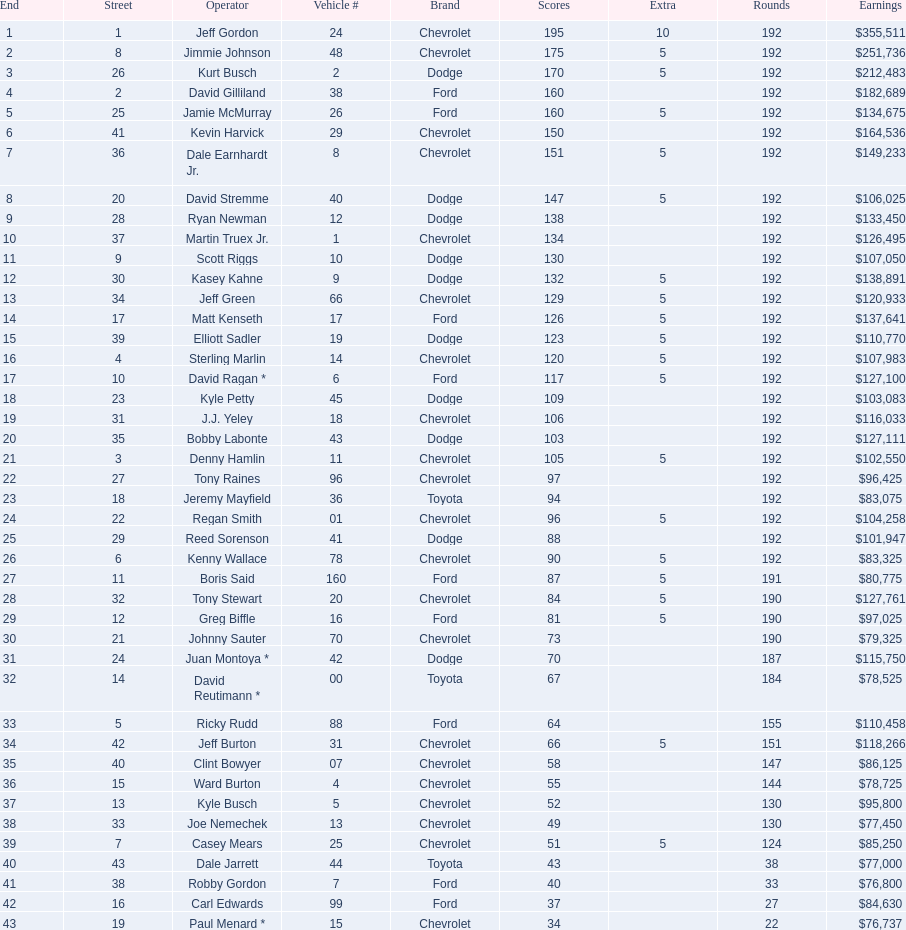What make did kurt busch drive? Dodge. 